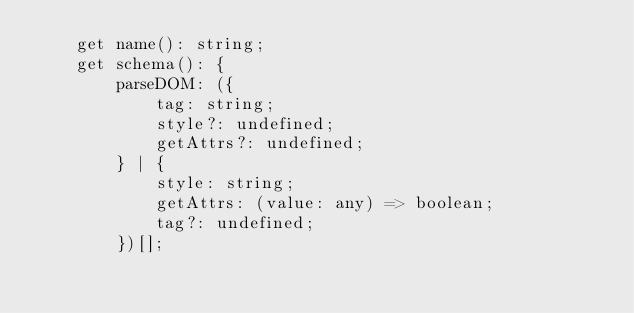Convert code to text. <code><loc_0><loc_0><loc_500><loc_500><_TypeScript_>    get name(): string;
    get schema(): {
        parseDOM: ({
            tag: string;
            style?: undefined;
            getAttrs?: undefined;
        } | {
            style: string;
            getAttrs: (value: any) => boolean;
            tag?: undefined;
        })[];</code> 